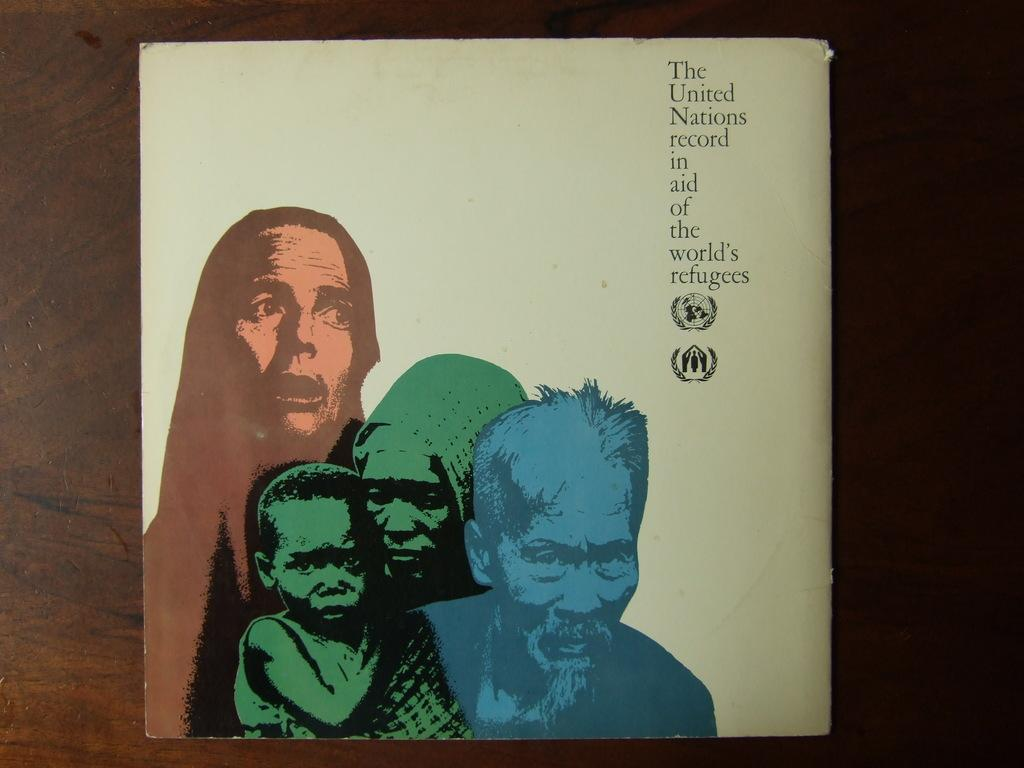What is present on the wall in the image? There is a poster in the image. What type of material is the wall made of? The wall is made of wood. What type of powder is visible on the poster in the image? There is no powder visible on the poster in the image. Can you see an airplane flying in the background of the image? There is no airplane visible in the image. 